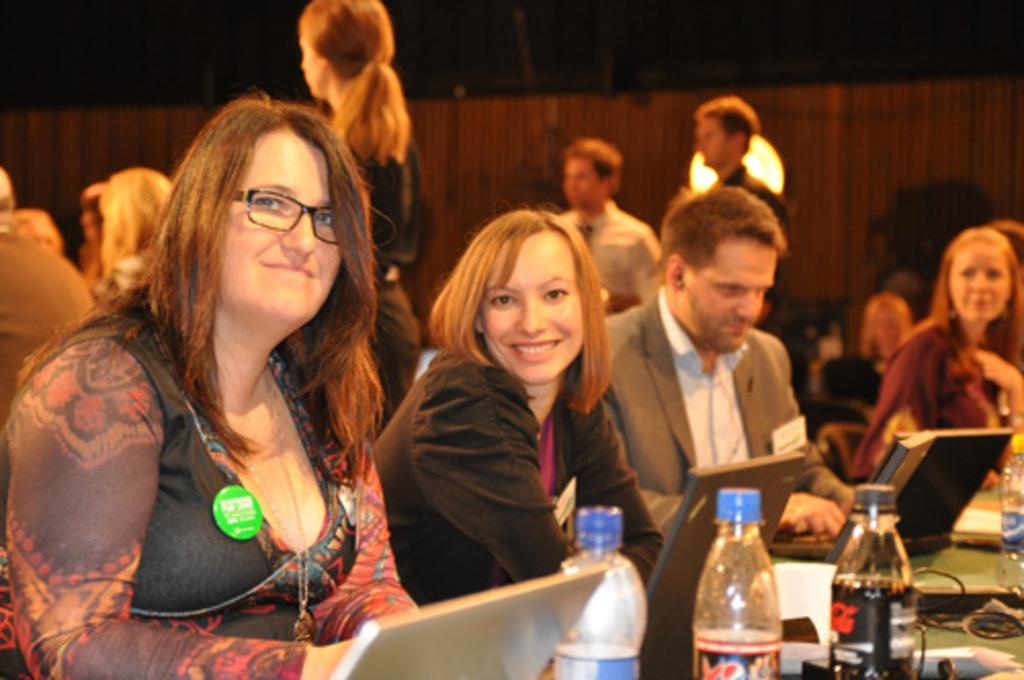What are the people in the image doing? The people in the image are sitting on chairs. What can be seen on the table in the image? There are objects on the table in the image. What type of wall is visible in the background of the image? There is a wooden wall in the background of the image. What is the topic of the discussion happening between the people in the image? There is no discussion happening between the people in the image; they are simply sitting on chairs. Can you see a net in the image? There is no net present in the image. 